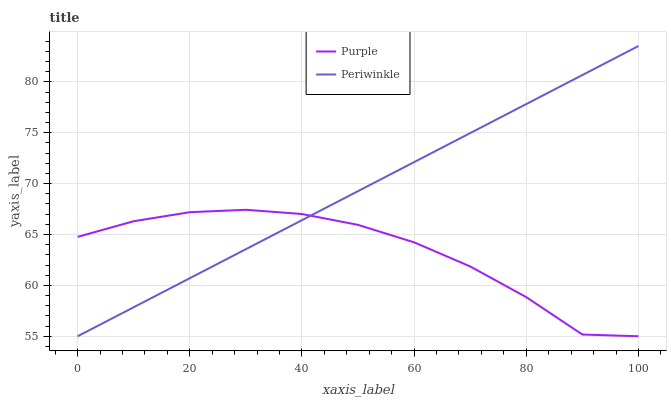Does Periwinkle have the minimum area under the curve?
Answer yes or no. No. Is Periwinkle the roughest?
Answer yes or no. No. 